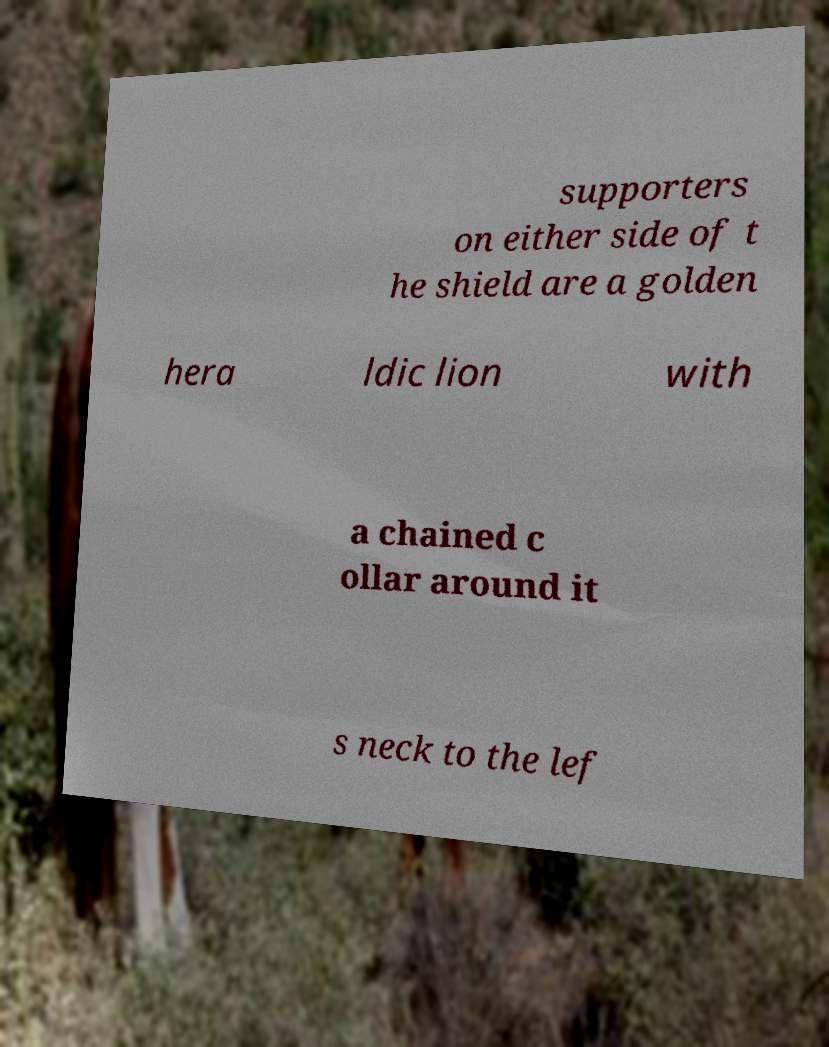Can you accurately transcribe the text from the provided image for me? supporters on either side of t he shield are a golden hera ldic lion with a chained c ollar around it s neck to the lef 